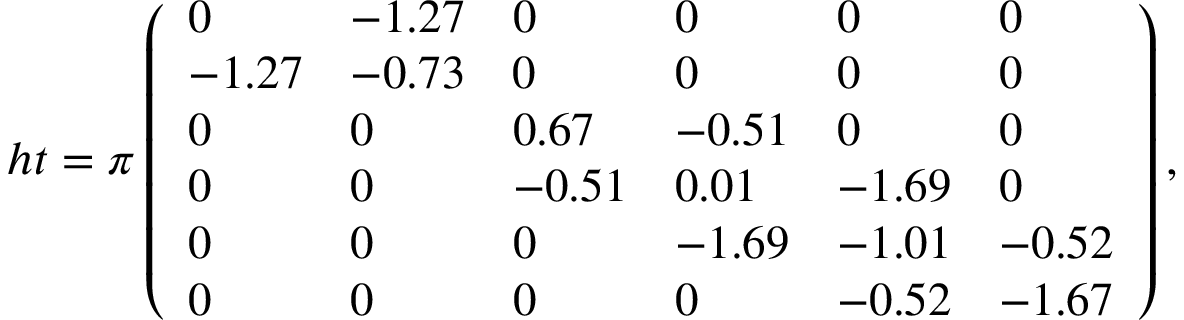<formula> <loc_0><loc_0><loc_500><loc_500>h t = \pi \left ( \begin{array} { l l l l l l } { 0 } & { - 1 . 2 7 } & { 0 } & { 0 } & { 0 } & { 0 } \\ { - 1 . 2 7 } & { - 0 . 7 3 } & { 0 } & { 0 } & { 0 } & { 0 } \\ { 0 } & { 0 } & { 0 . 6 7 } & { - 0 . 5 1 } & { 0 } & { 0 } \\ { 0 } & { 0 } & { - 0 . 5 1 } & { 0 . 0 1 } & { - 1 . 6 9 } & { 0 } \\ { 0 } & { 0 } & { 0 } & { - 1 . 6 9 } & { - 1 . 0 1 } & { - 0 . 5 2 } \\ { 0 } & { 0 } & { 0 } & { 0 } & { - 0 . 5 2 } & { - 1 . 6 7 } \end{array} \right ) ,</formula> 